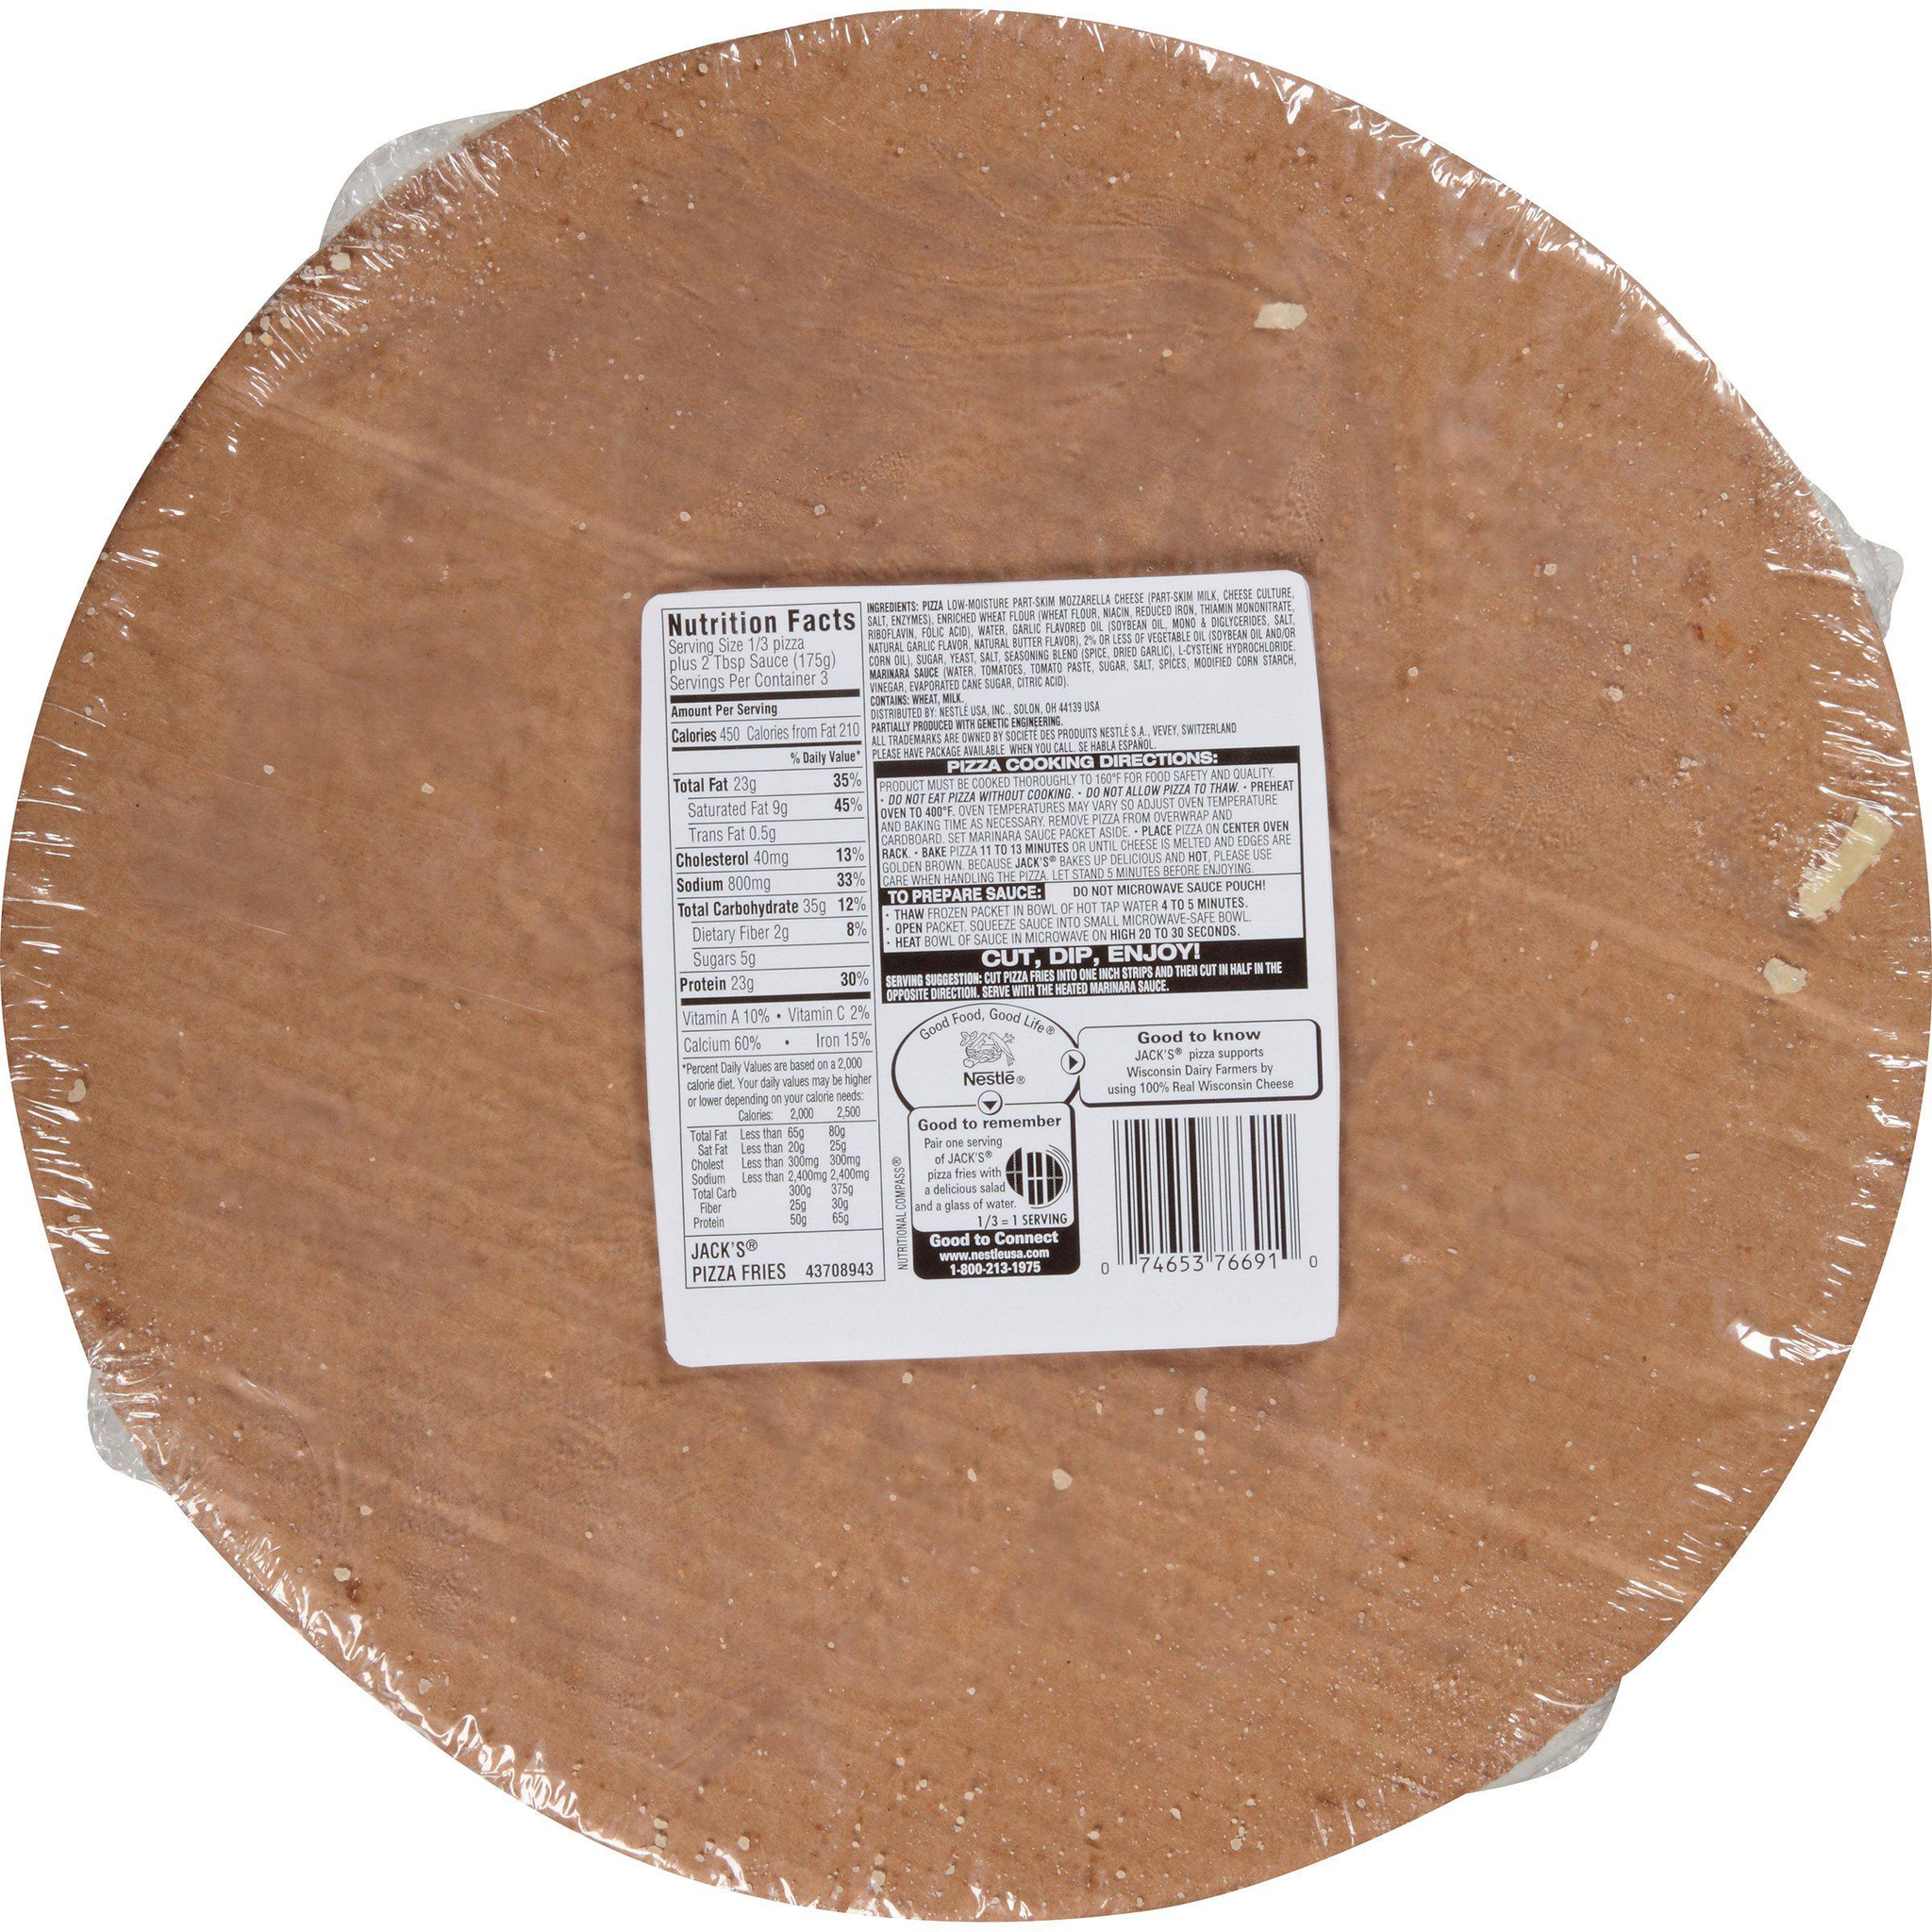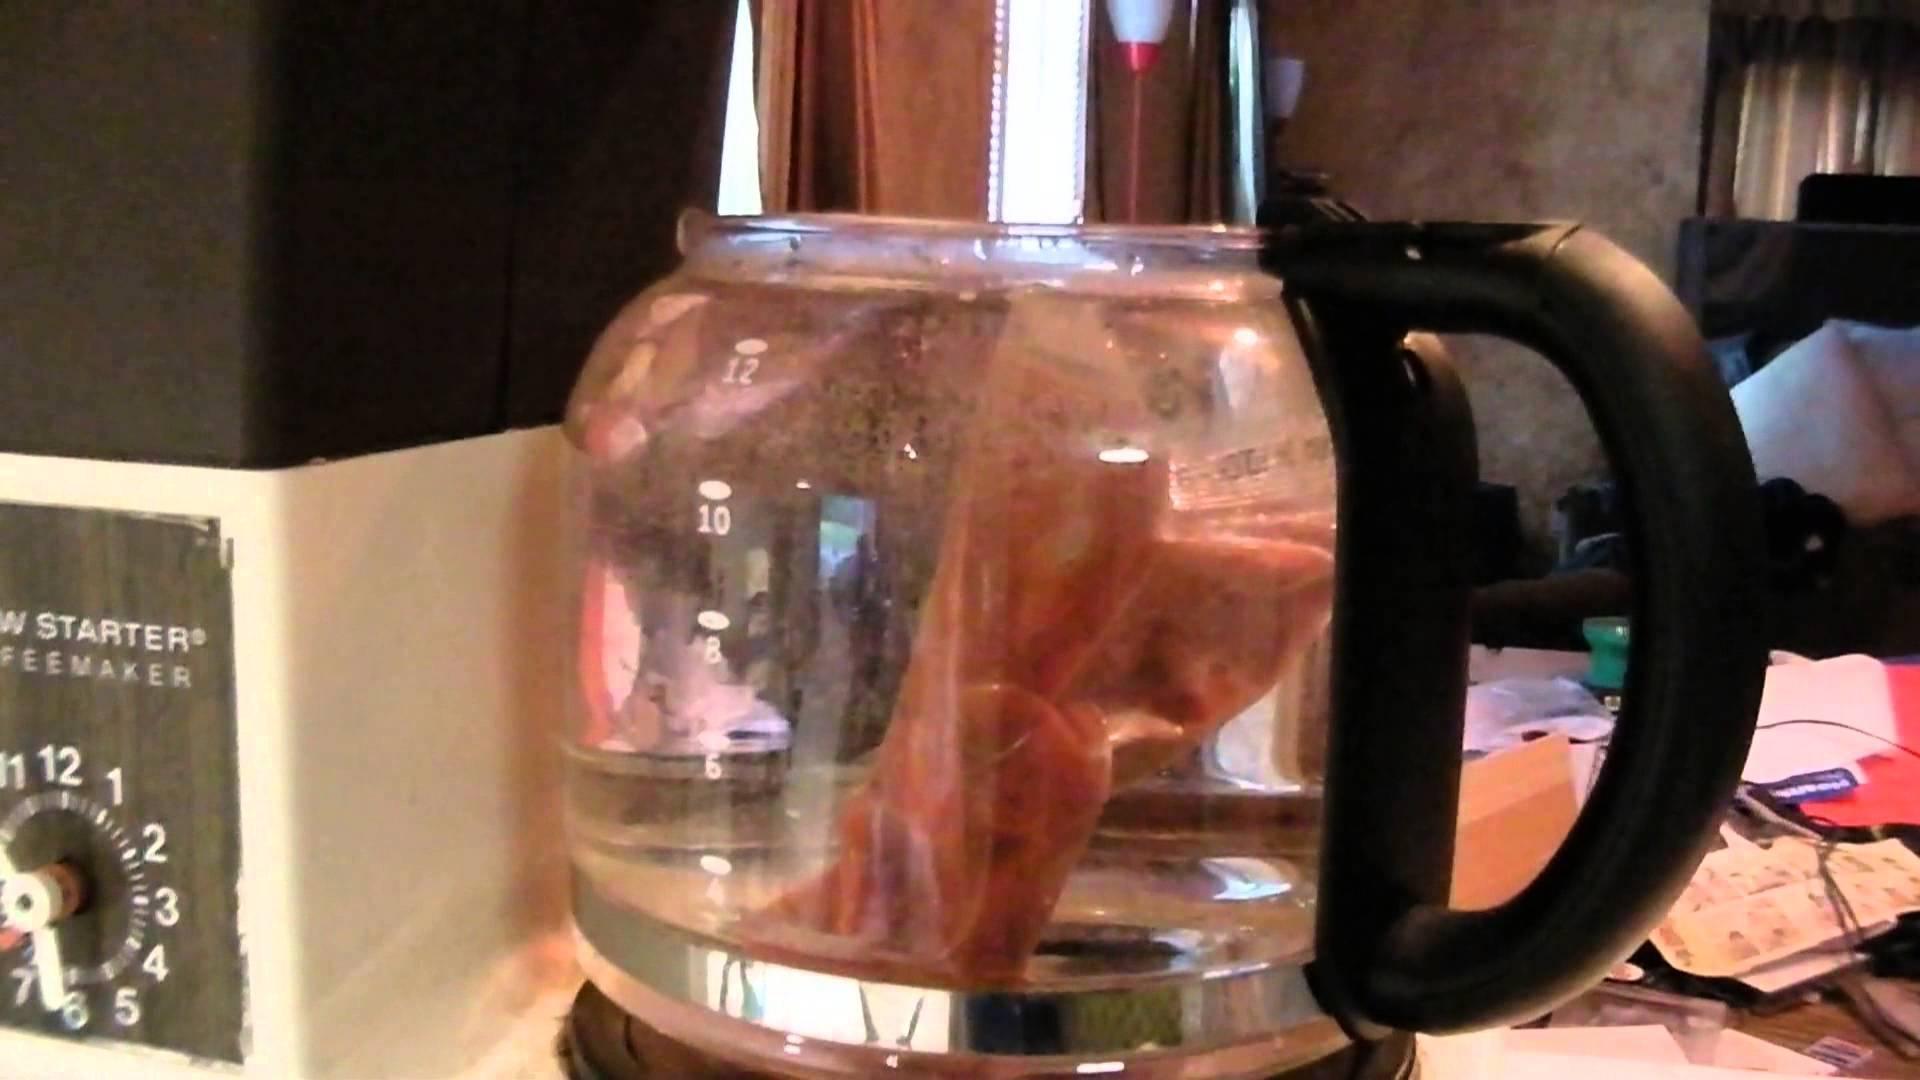The first image is the image on the left, the second image is the image on the right. For the images displayed, is the sentence "One of the images shows pepperoni." factually correct? Answer yes or no. No. The first image is the image on the left, the second image is the image on the right. Assess this claim about the two images: "The left image includes a round shape with a type of pizza food depicted on it, and the right image shows fast food in a squarish container.". Correct or not? Answer yes or no. No. 